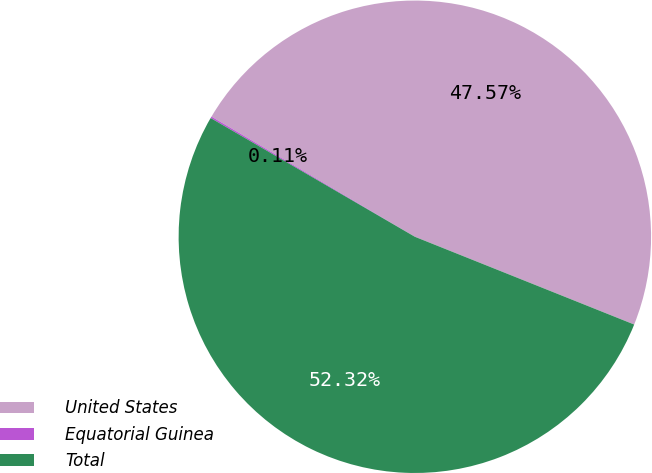Convert chart to OTSL. <chart><loc_0><loc_0><loc_500><loc_500><pie_chart><fcel>United States<fcel>Equatorial Guinea<fcel>Total<nl><fcel>47.57%<fcel>0.11%<fcel>52.33%<nl></chart> 